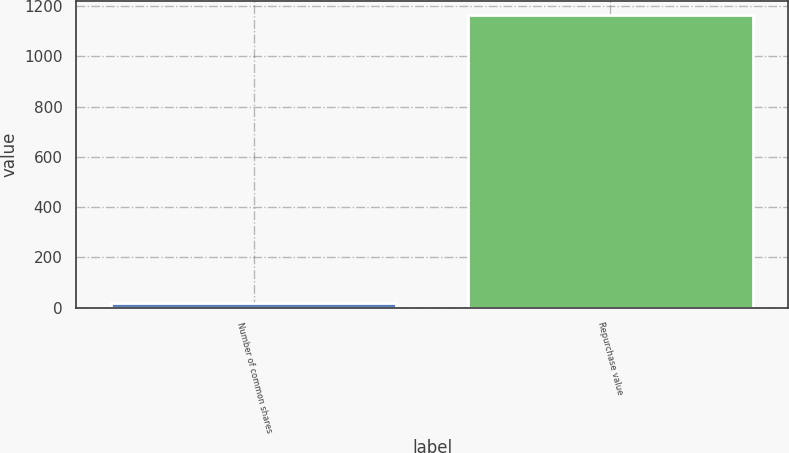Convert chart to OTSL. <chart><loc_0><loc_0><loc_500><loc_500><bar_chart><fcel>Number of common shares<fcel>Repurchase value<nl><fcel>18<fcel>1163<nl></chart> 